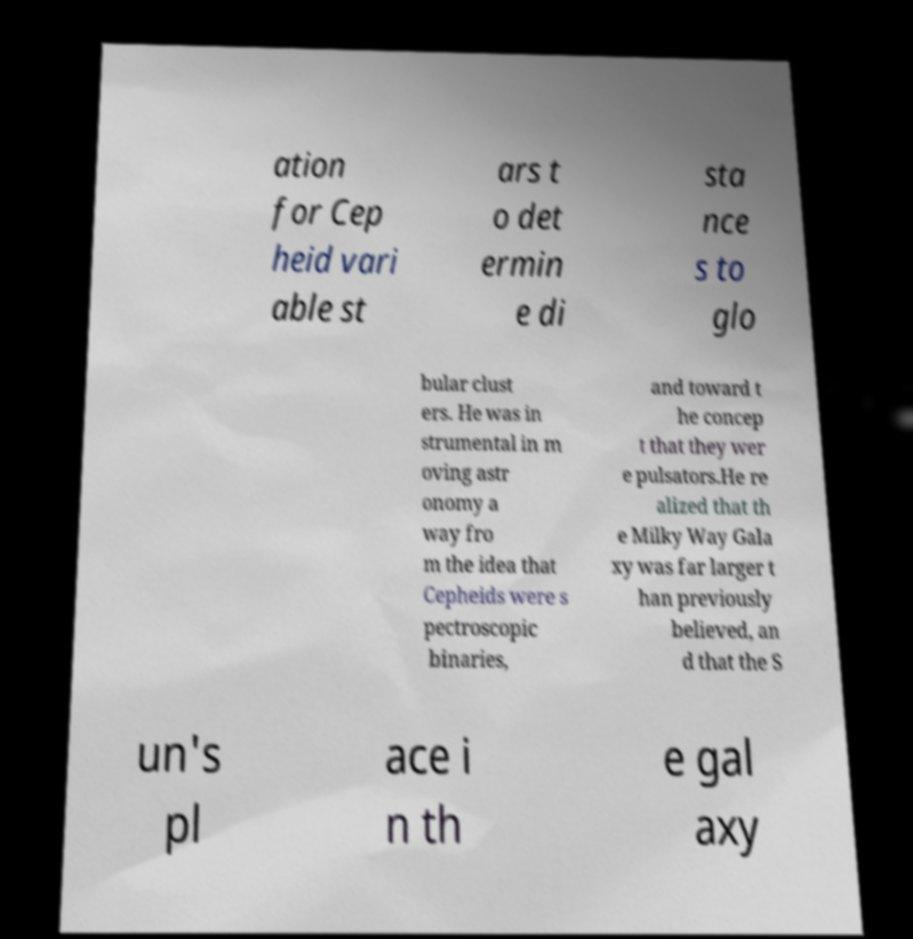What messages or text are displayed in this image? I need them in a readable, typed format. ation for Cep heid vari able st ars t o det ermin e di sta nce s to glo bular clust ers. He was in strumental in m oving astr onomy a way fro m the idea that Cepheids were s pectroscopic binaries, and toward t he concep t that they wer e pulsators.He re alized that th e Milky Way Gala xy was far larger t han previously believed, an d that the S un's pl ace i n th e gal axy 